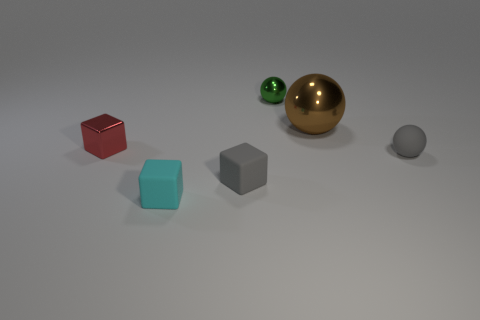Is there anything else that is the same size as the brown object?
Give a very brief answer. No. There is a tiny block that is the same color as the rubber ball; what is its material?
Your answer should be very brief. Rubber. What material is the gray block that is the same size as the cyan rubber thing?
Keep it short and to the point. Rubber. Is the material of the brown sphere the same as the small green object?
Offer a terse response. Yes. What number of things are small gray rubber things or green metal spheres?
Make the answer very short. 3. What is the shape of the tiny gray object that is left of the green sphere?
Keep it short and to the point. Cube. There is a large sphere that is made of the same material as the red thing; what is its color?
Your response must be concise. Brown. There is a small red thing that is the same shape as the cyan matte object; what is it made of?
Keep it short and to the point. Metal. What is the shape of the large brown metal object?
Give a very brief answer. Sphere. The tiny cube that is both right of the shiny block and behind the cyan block is made of what material?
Your answer should be compact. Rubber. 